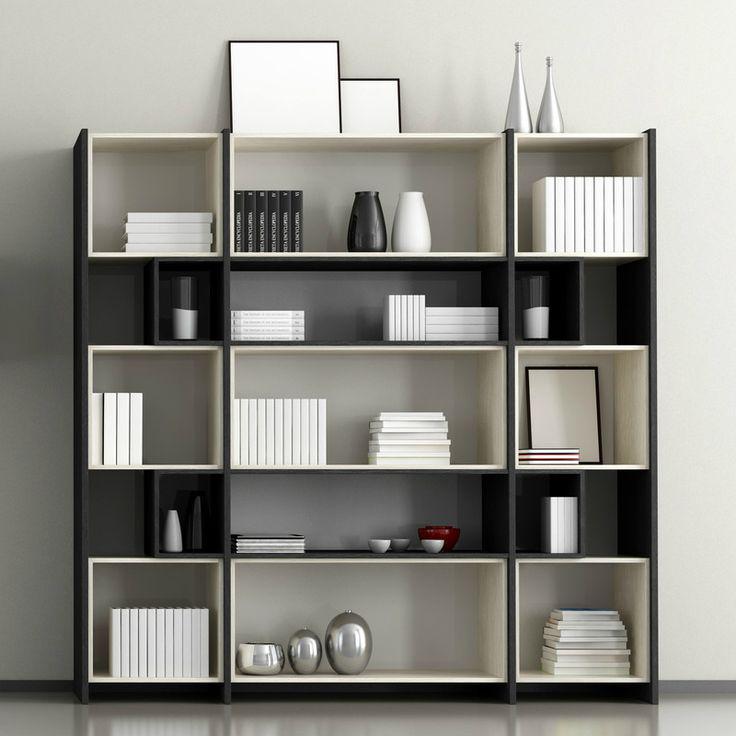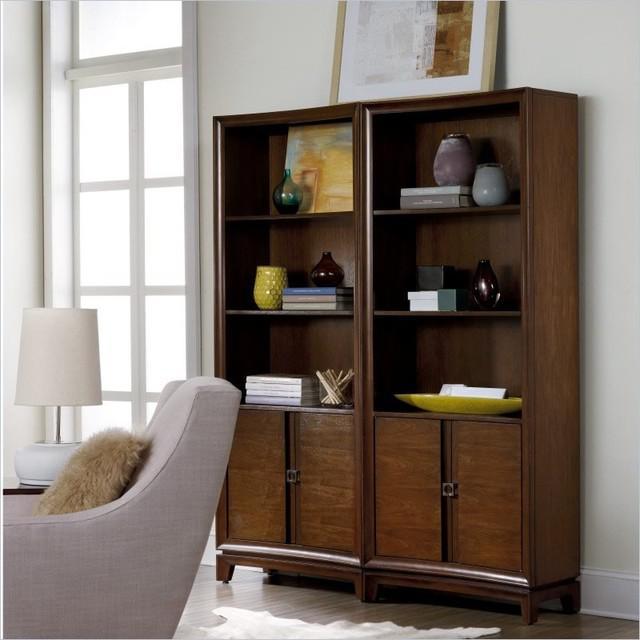The first image is the image on the left, the second image is the image on the right. Assess this claim about the two images: "There is a pot of plant with white flowers on top of a shelf.". Correct or not? Answer yes or no. No. 